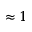Convert formula to latex. <formula><loc_0><loc_0><loc_500><loc_500>\approx 1</formula> 